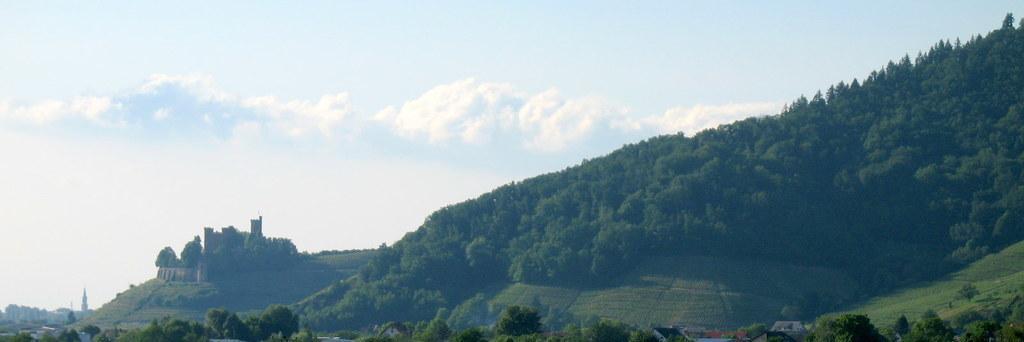Describe this image in one or two sentences. In this image I can see trees and mountains. At the top I can see clouds in the sky. I can see a building. 